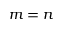<formula> <loc_0><loc_0><loc_500><loc_500>m = n</formula> 